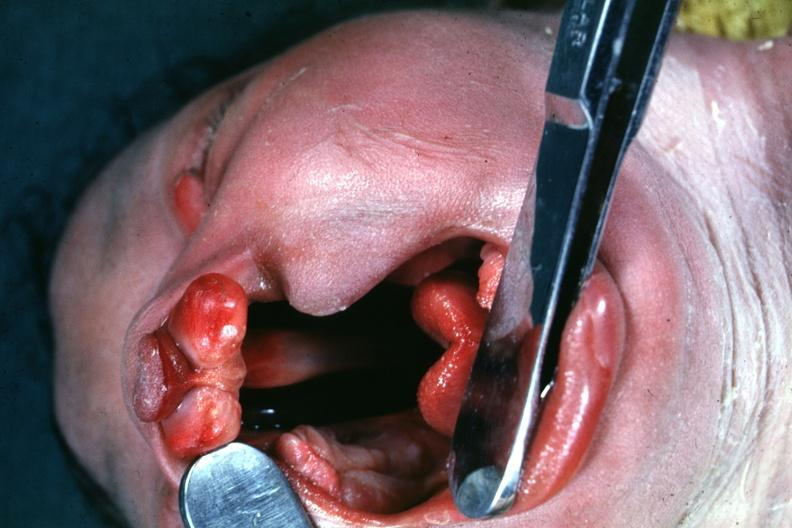does this image show head tilted with mouth?
Answer the question using a single word or phrase. Yes 